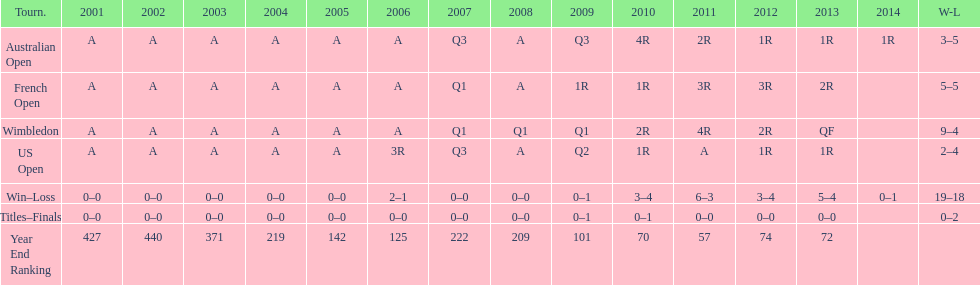How many tournaments had 5 total losses? 2. 